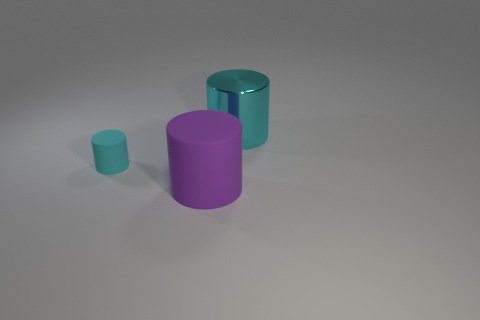Add 1 cyan objects. How many objects exist? 4 Add 2 purple things. How many purple things are left? 3 Add 2 blue matte things. How many blue matte things exist? 2 Subtract 0 brown spheres. How many objects are left? 3 Subtract all small matte cylinders. Subtract all metallic things. How many objects are left? 1 